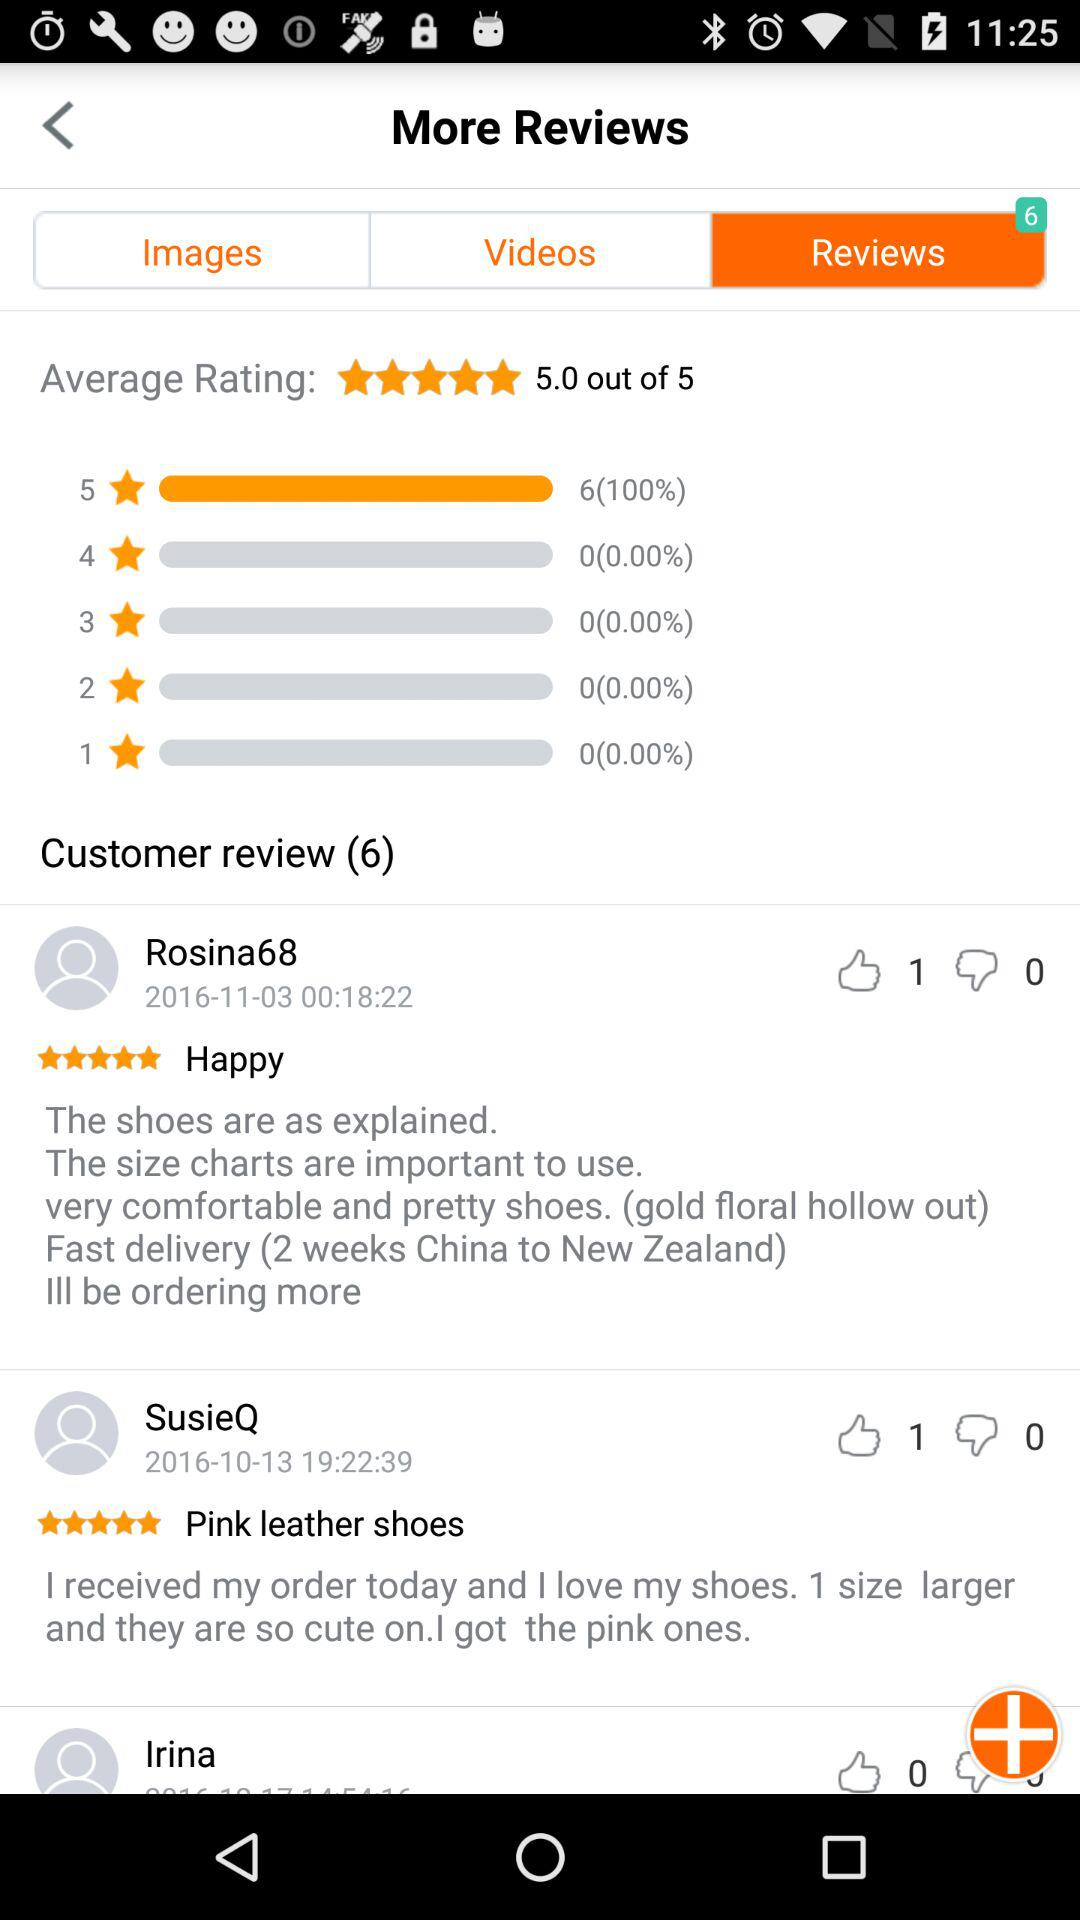Which tab is selected? The selected tab is "Reviews". 